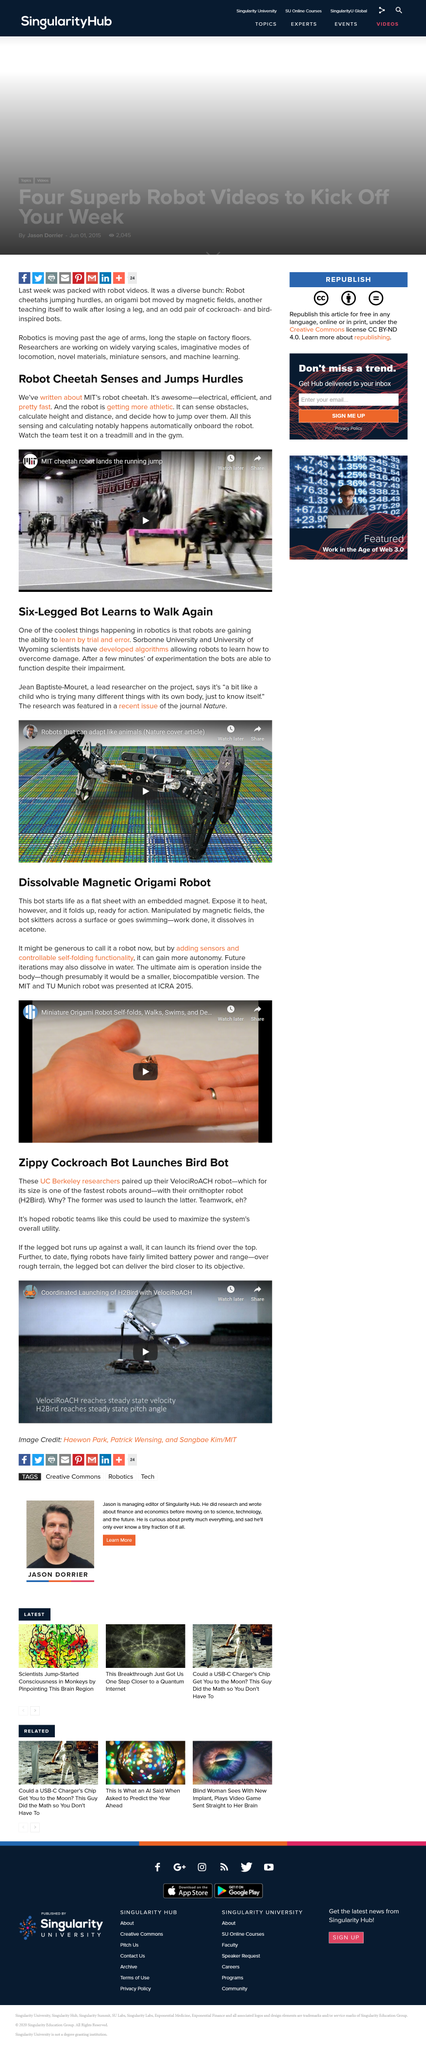Outline some significant characteristics in this image. UC Berkeley researchers have paired up two robots, the VelociRoACH robot and their ornithopter robot H2Bird, in a collaborative project. As of today, the range and battery life of flying robots are still quite limited. The UC Berkeley researchers have developed an ornithopter robot called H2Bird, which is currently the only flying robot capable of mimicking the flight of birds. The given video features MIT's team testing a robot cheetah on a treadmill and in the gym. The robot was presented at ICRA 2015, where it was introduced to the public for the first time. 